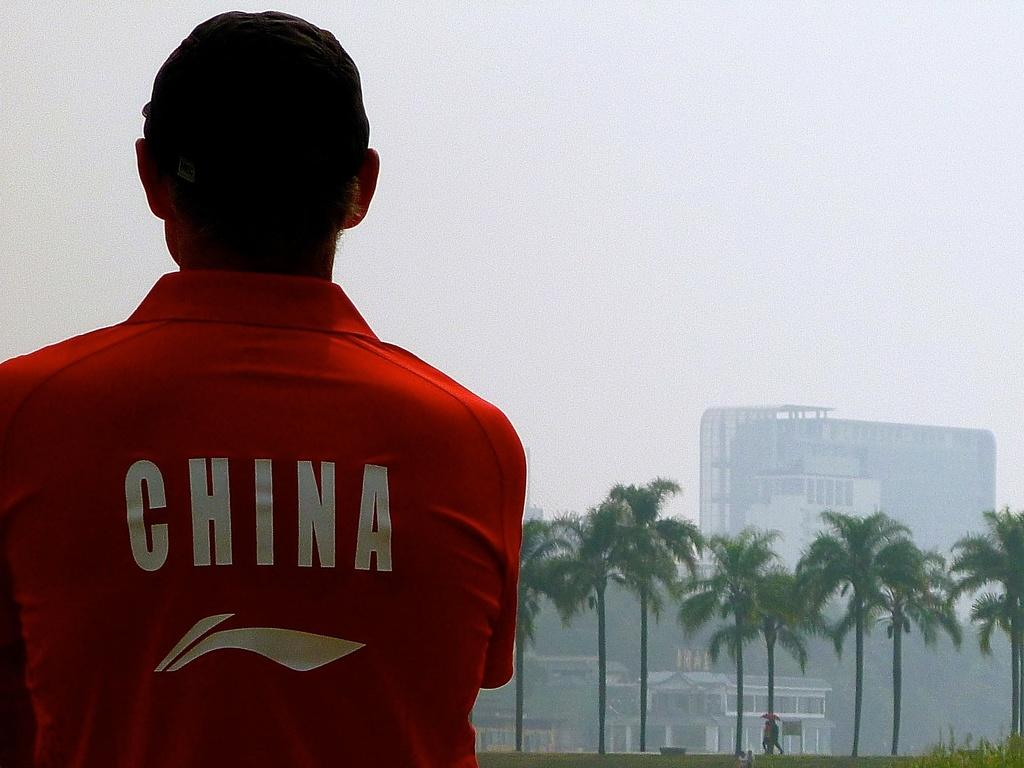What is the main subject in the image? There is a person standing in the image. What can be seen in the background of the image? There are trees, buildings, and persons walking on the road in the background of the image. What are the persons walking on the road holding? The persons walking on the road are holding umbrellas. What is visible in the sky in the background of the image? The sky is visible in the background of the image. Can you see any stars in the image? There are no stars visible in the image. What type of shade is provided by the trees in the image? The image does not provide information about the type of shade provided by the trees. 